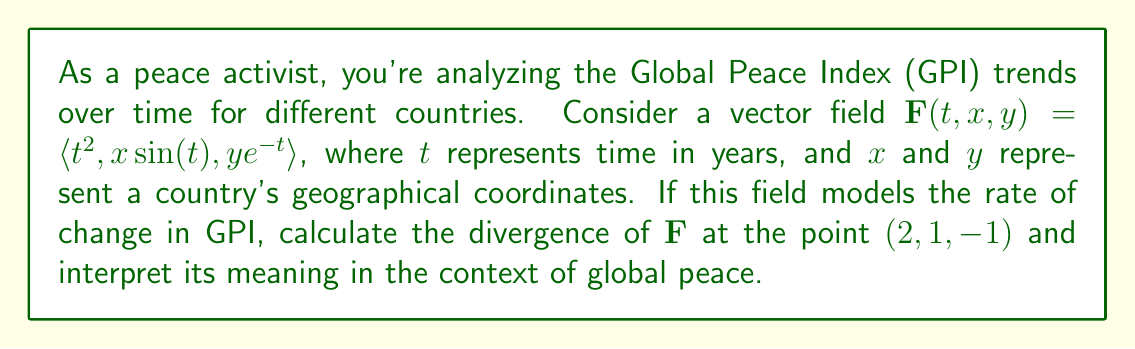Provide a solution to this math problem. To solve this problem, we'll follow these steps:

1) The divergence of a vector field $\mathbf{F}(x, y, z) = \langle P, Q, R \rangle$ is given by:

   $$\text{div}\mathbf{F} = \nabla \cdot \mathbf{F} = \frac{\partial P}{\partial x} + \frac{\partial Q}{\partial y} + \frac{\partial R}{\partial z}$$

2) In our case, $\mathbf{F}(t, x, y) = \langle t^2, x\sin(t), ye^{-t} \rangle$, so:
   
   $P = t^2$
   $Q = x\sin(t)$
   $R = ye^{-t}$

3) We need to calculate:

   $$\frac{\partial P}{\partial t} + \frac{\partial Q}{\partial x} + \frac{\partial R}{\partial y}$$

4) Calculate each partial derivative:

   $\frac{\partial P}{\partial t} = 2t$
   $\frac{\partial Q}{\partial x} = \sin(t)$
   $\frac{\partial R}{\partial y} = e^{-t}$

5) Sum these up:

   $$\text{div}\mathbf{F} = 2t + \sin(t) + e^{-t}$$

6) Evaluate at the point $(2, 1, -1)$:

   $$\text{div}\mathbf{F}(2, 1, -1) = 2(2) + \sin(2) + e^{-2}$$

7) Calculate:

   $$\text{div}\mathbf{F}(2, 1, -1) = 4 + \sin(2) + e^{-2} \approx 4.909$$

Interpretation: The positive divergence indicates that the GPI is increasing at this point, suggesting a decrease in global peace. As a peace activist, this result would be concerning, indicating a need for increased efforts towards peace-building initiatives.
Answer: $$\text{div}\mathbf{F}(2, 1, -1) = 4 + \sin(2) + e^{-2} \approx 4.909$$ 